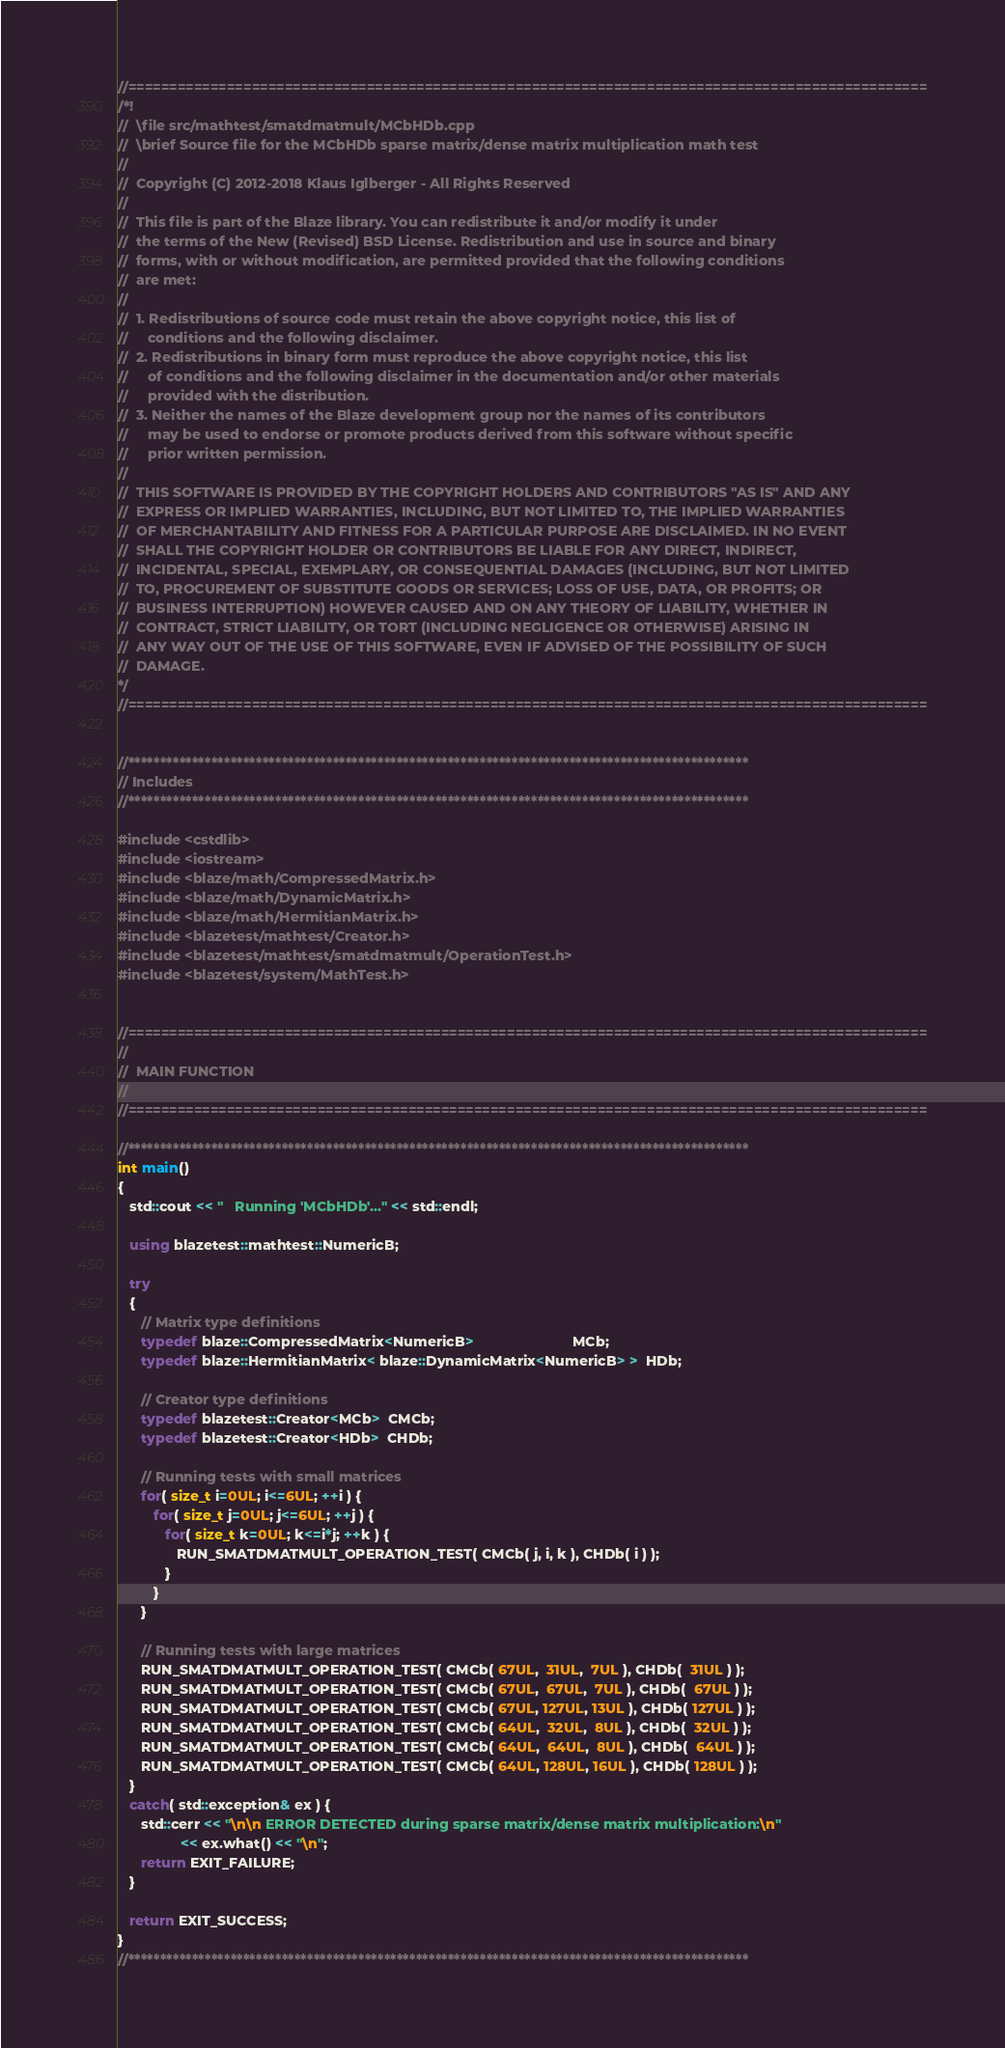Convert code to text. <code><loc_0><loc_0><loc_500><loc_500><_C++_>//=================================================================================================
/*!
//  \file src/mathtest/smatdmatmult/MCbHDb.cpp
//  \brief Source file for the MCbHDb sparse matrix/dense matrix multiplication math test
//
//  Copyright (C) 2012-2018 Klaus Iglberger - All Rights Reserved
//
//  This file is part of the Blaze library. You can redistribute it and/or modify it under
//  the terms of the New (Revised) BSD License. Redistribution and use in source and binary
//  forms, with or without modification, are permitted provided that the following conditions
//  are met:
//
//  1. Redistributions of source code must retain the above copyright notice, this list of
//     conditions and the following disclaimer.
//  2. Redistributions in binary form must reproduce the above copyright notice, this list
//     of conditions and the following disclaimer in the documentation and/or other materials
//     provided with the distribution.
//  3. Neither the names of the Blaze development group nor the names of its contributors
//     may be used to endorse or promote products derived from this software without specific
//     prior written permission.
//
//  THIS SOFTWARE IS PROVIDED BY THE COPYRIGHT HOLDERS AND CONTRIBUTORS "AS IS" AND ANY
//  EXPRESS OR IMPLIED WARRANTIES, INCLUDING, BUT NOT LIMITED TO, THE IMPLIED WARRANTIES
//  OF MERCHANTABILITY AND FITNESS FOR A PARTICULAR PURPOSE ARE DISCLAIMED. IN NO EVENT
//  SHALL THE COPYRIGHT HOLDER OR CONTRIBUTORS BE LIABLE FOR ANY DIRECT, INDIRECT,
//  INCIDENTAL, SPECIAL, EXEMPLARY, OR CONSEQUENTIAL DAMAGES (INCLUDING, BUT NOT LIMITED
//  TO, PROCUREMENT OF SUBSTITUTE GOODS OR SERVICES; LOSS OF USE, DATA, OR PROFITS; OR
//  BUSINESS INTERRUPTION) HOWEVER CAUSED AND ON ANY THEORY OF LIABILITY, WHETHER IN
//  CONTRACT, STRICT LIABILITY, OR TORT (INCLUDING NEGLIGENCE OR OTHERWISE) ARISING IN
//  ANY WAY OUT OF THE USE OF THIS SOFTWARE, EVEN IF ADVISED OF THE POSSIBILITY OF SUCH
//  DAMAGE.
*/
//=================================================================================================


//*************************************************************************************************
// Includes
//*************************************************************************************************

#include <cstdlib>
#include <iostream>
#include <blaze/math/CompressedMatrix.h>
#include <blaze/math/DynamicMatrix.h>
#include <blaze/math/HermitianMatrix.h>
#include <blazetest/mathtest/Creator.h>
#include <blazetest/mathtest/smatdmatmult/OperationTest.h>
#include <blazetest/system/MathTest.h>


//=================================================================================================
//
//  MAIN FUNCTION
//
//=================================================================================================

//*************************************************************************************************
int main()
{
   std::cout << "   Running 'MCbHDb'..." << std::endl;

   using blazetest::mathtest::NumericB;

   try
   {
      // Matrix type definitions
      typedef blaze::CompressedMatrix<NumericB>                         MCb;
      typedef blaze::HermitianMatrix< blaze::DynamicMatrix<NumericB> >  HDb;

      // Creator type definitions
      typedef blazetest::Creator<MCb>  CMCb;
      typedef blazetest::Creator<HDb>  CHDb;

      // Running tests with small matrices
      for( size_t i=0UL; i<=6UL; ++i ) {
         for( size_t j=0UL; j<=6UL; ++j ) {
            for( size_t k=0UL; k<=i*j; ++k ) {
               RUN_SMATDMATMULT_OPERATION_TEST( CMCb( j, i, k ), CHDb( i ) );
            }
         }
      }

      // Running tests with large matrices
      RUN_SMATDMATMULT_OPERATION_TEST( CMCb( 67UL,  31UL,  7UL ), CHDb(  31UL ) );
      RUN_SMATDMATMULT_OPERATION_TEST( CMCb( 67UL,  67UL,  7UL ), CHDb(  67UL ) );
      RUN_SMATDMATMULT_OPERATION_TEST( CMCb( 67UL, 127UL, 13UL ), CHDb( 127UL ) );
      RUN_SMATDMATMULT_OPERATION_TEST( CMCb( 64UL,  32UL,  8UL ), CHDb(  32UL ) );
      RUN_SMATDMATMULT_OPERATION_TEST( CMCb( 64UL,  64UL,  8UL ), CHDb(  64UL ) );
      RUN_SMATDMATMULT_OPERATION_TEST( CMCb( 64UL, 128UL, 16UL ), CHDb( 128UL ) );
   }
   catch( std::exception& ex ) {
      std::cerr << "\n\n ERROR DETECTED during sparse matrix/dense matrix multiplication:\n"
                << ex.what() << "\n";
      return EXIT_FAILURE;
   }

   return EXIT_SUCCESS;
}
//*************************************************************************************************
</code> 